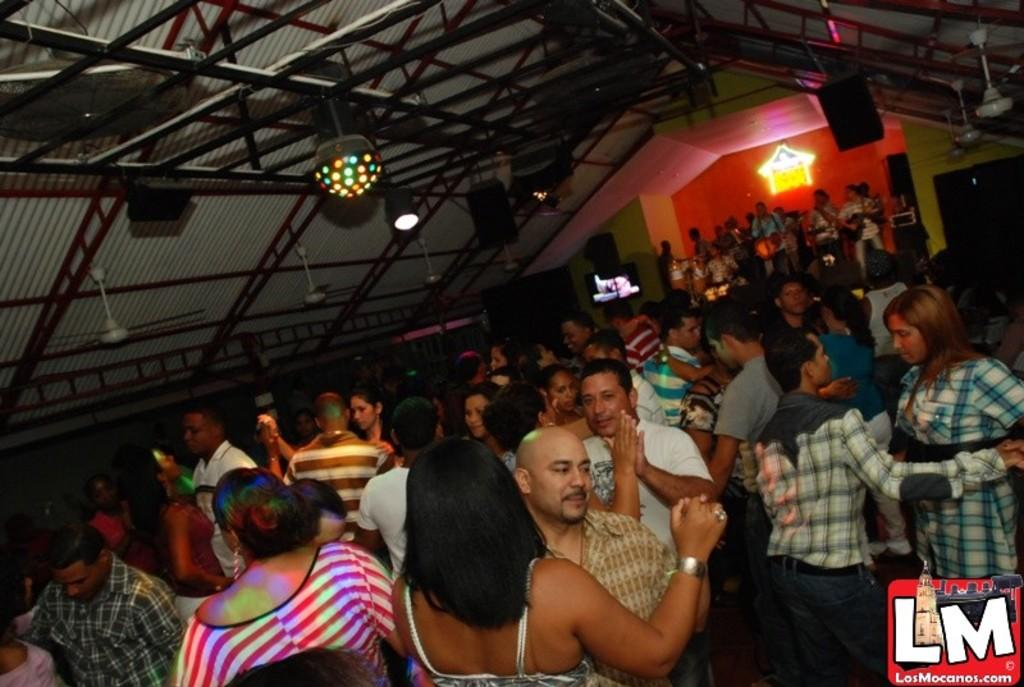Who is present in the image? There are people in the image. What are the people doing in the image? The people are dancing in the image. Where is the dancing taking place? The dancing is taking place inside a hall. What color is the sock on the person's left foot in the image? There is no sock visible in the image, as the people are dancing and their feet are not shown. 